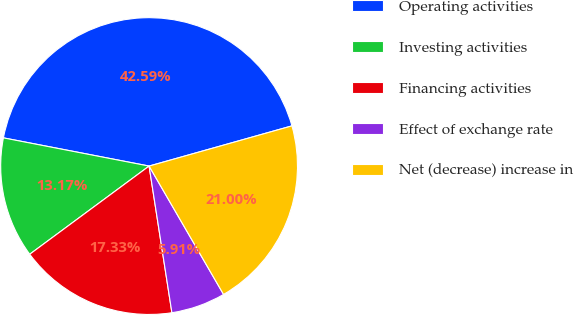Convert chart. <chart><loc_0><loc_0><loc_500><loc_500><pie_chart><fcel>Operating activities<fcel>Investing activities<fcel>Financing activities<fcel>Effect of exchange rate<fcel>Net (decrease) increase in<nl><fcel>42.59%<fcel>13.17%<fcel>17.33%<fcel>5.91%<fcel>21.0%<nl></chart> 